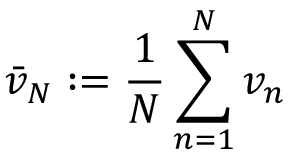Convert formula to latex. <formula><loc_0><loc_0><loc_500><loc_500>{ \bar { v } } _ { N } \colon = { \frac { 1 } { N } } \sum _ { n = 1 } ^ { N } v _ { n }</formula> 